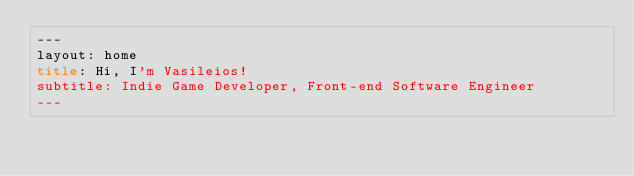<code> <loc_0><loc_0><loc_500><loc_500><_HTML_>---
layout: home
title: Hi, I'm Vasileios!
subtitle: Indie Game Developer, Front-end Software Engineer
---
</code> 